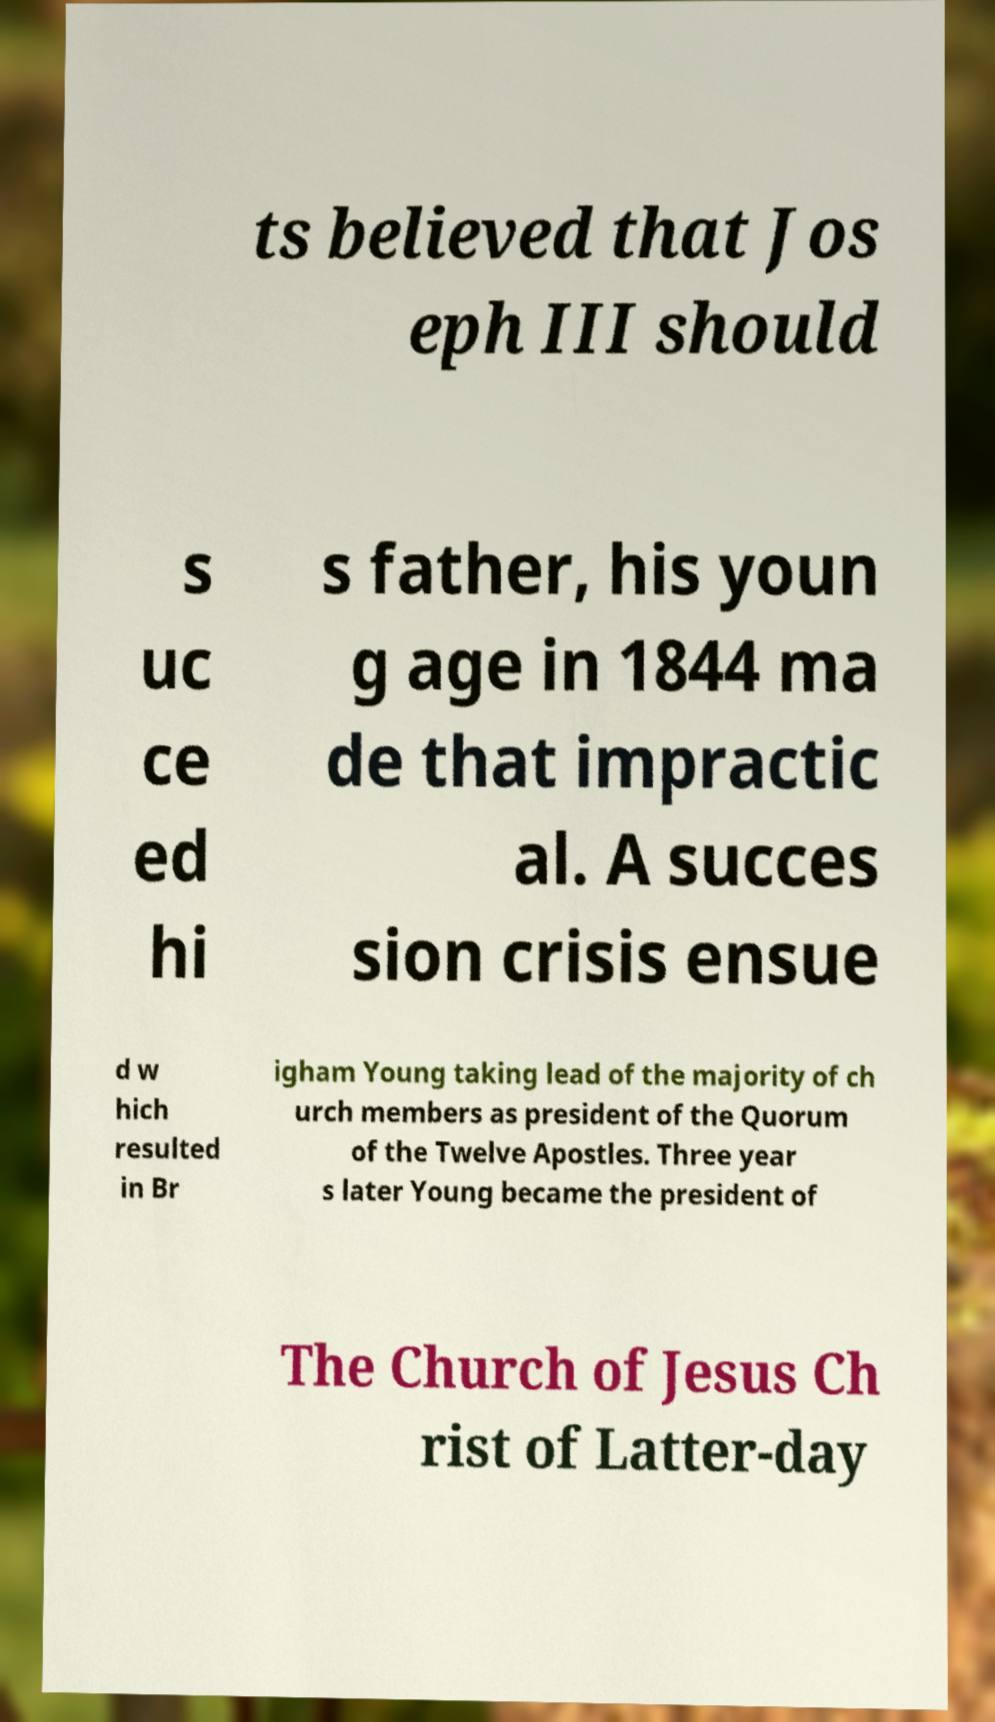Can you read and provide the text displayed in the image?This photo seems to have some interesting text. Can you extract and type it out for me? ts believed that Jos eph III should s uc ce ed hi s father, his youn g age in 1844 ma de that impractic al. A succes sion crisis ensue d w hich resulted in Br igham Young taking lead of the majority of ch urch members as president of the Quorum of the Twelve Apostles. Three year s later Young became the president of The Church of Jesus Ch rist of Latter-day 